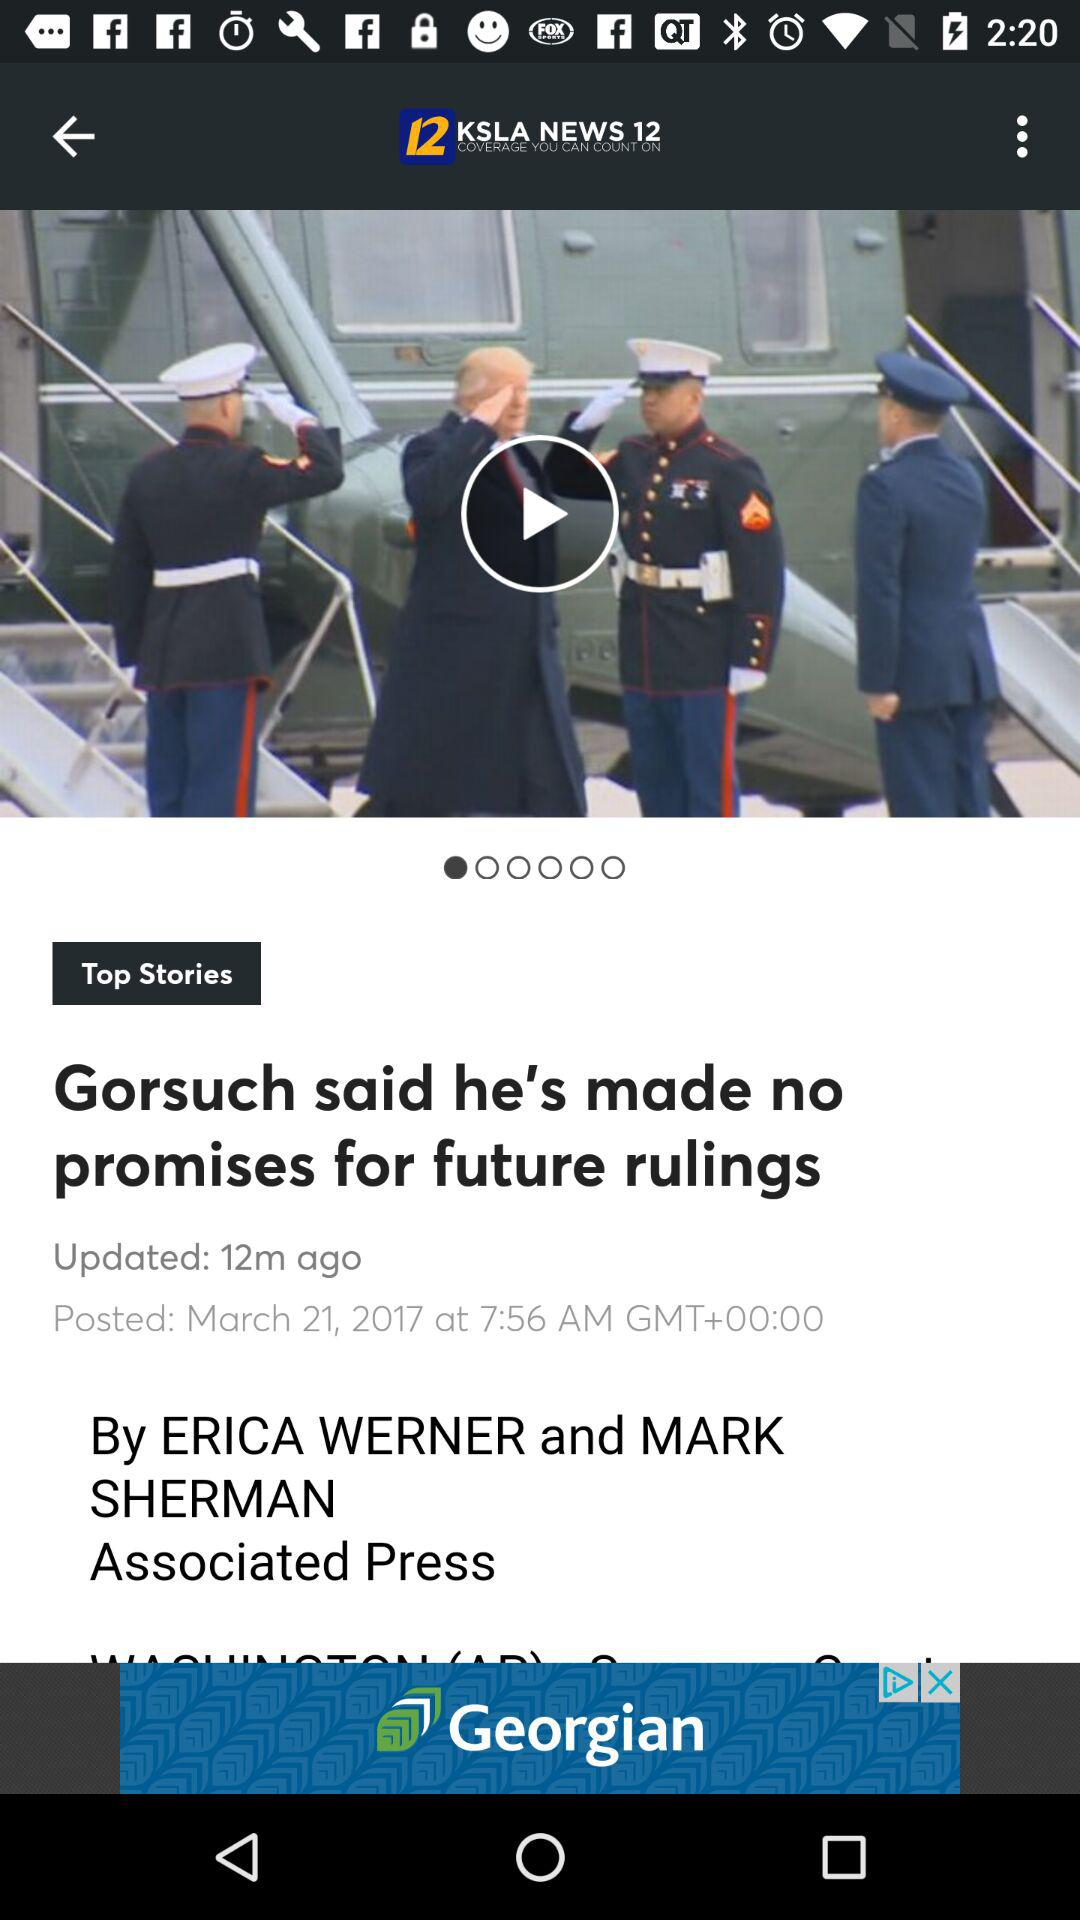At what time was the article posted in 2017? The article was posted at 7:56 a.m. 